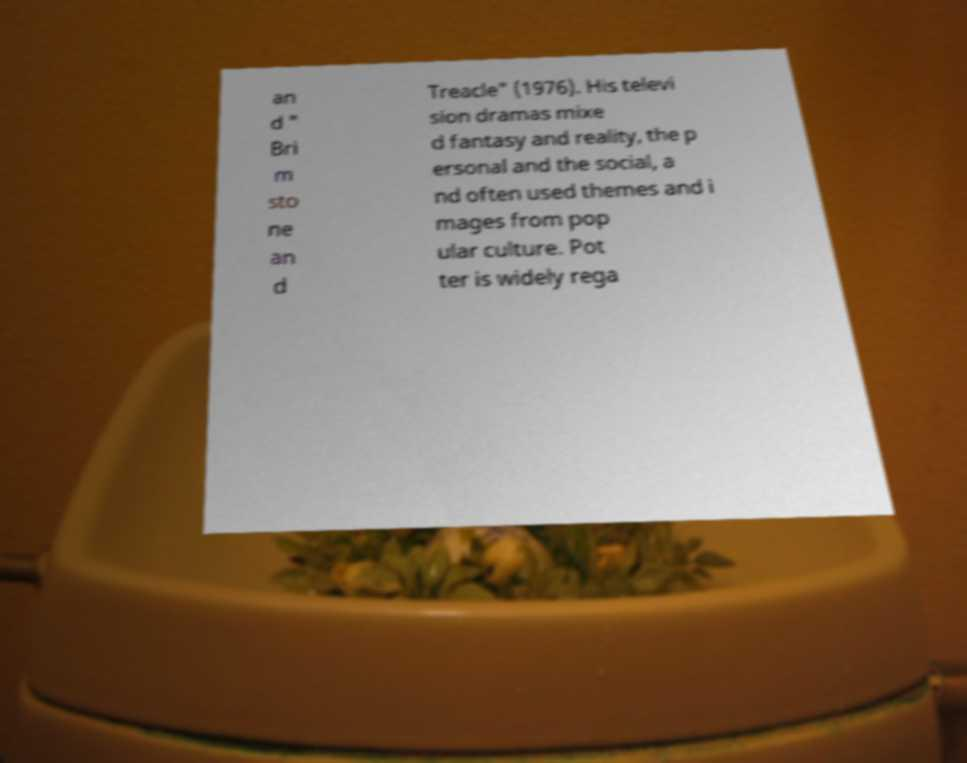Could you extract and type out the text from this image? an d " Bri m sto ne an d Treacle" (1976). His televi sion dramas mixe d fantasy and reality, the p ersonal and the social, a nd often used themes and i mages from pop ular culture. Pot ter is widely rega 